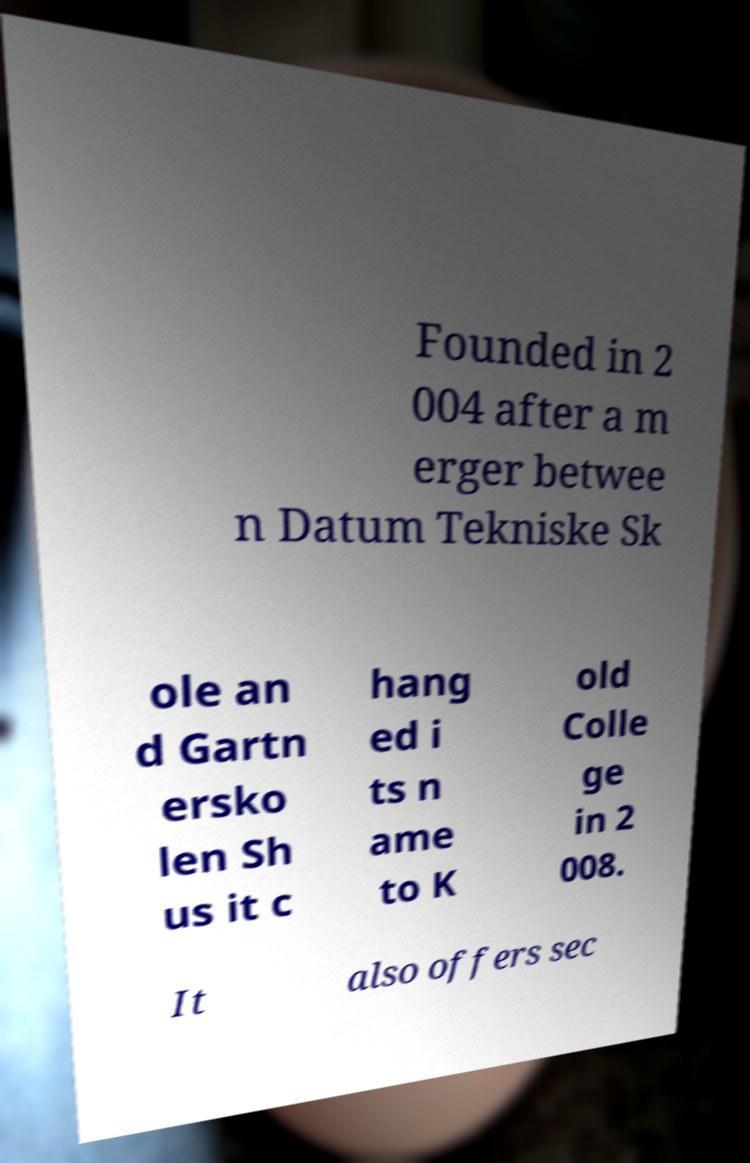Can you accurately transcribe the text from the provided image for me? Founded in 2 004 after a m erger betwee n Datum Tekniske Sk ole an d Gartn ersko len Sh us it c hang ed i ts n ame to K old Colle ge in 2 008. It also offers sec 